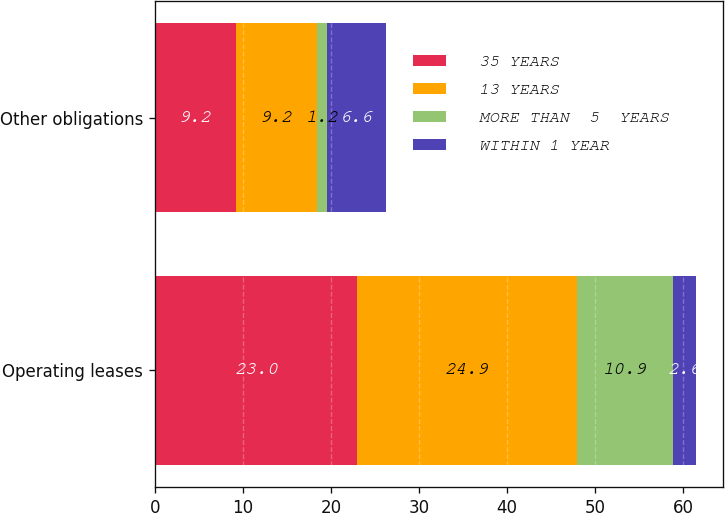Convert chart. <chart><loc_0><loc_0><loc_500><loc_500><stacked_bar_chart><ecel><fcel>Operating leases<fcel>Other obligations<nl><fcel>35 YEARS<fcel>23<fcel>9.2<nl><fcel>13 YEARS<fcel>24.9<fcel>9.2<nl><fcel>MORE THAN  5  YEARS<fcel>10.9<fcel>1.2<nl><fcel>WITHIN 1 YEAR<fcel>2.6<fcel>6.6<nl></chart> 